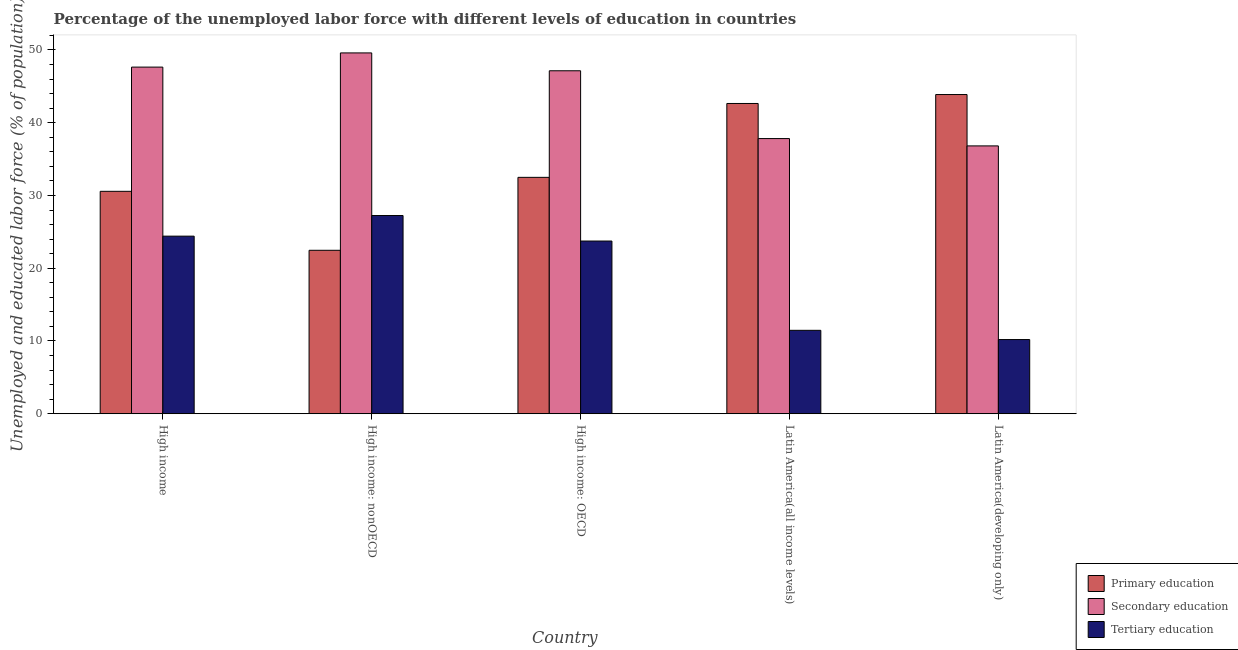How many groups of bars are there?
Offer a very short reply. 5. How many bars are there on the 4th tick from the left?
Provide a succinct answer. 3. What is the label of the 5th group of bars from the left?
Provide a short and direct response. Latin America(developing only). In how many cases, is the number of bars for a given country not equal to the number of legend labels?
Keep it short and to the point. 0. What is the percentage of labor force who received secondary education in High income: nonOECD?
Make the answer very short. 49.59. Across all countries, what is the maximum percentage of labor force who received primary education?
Your response must be concise. 43.87. Across all countries, what is the minimum percentage of labor force who received secondary education?
Your answer should be compact. 36.81. In which country was the percentage of labor force who received primary education maximum?
Your response must be concise. Latin America(developing only). In which country was the percentage of labor force who received tertiary education minimum?
Your answer should be very brief. Latin America(developing only). What is the total percentage of labor force who received primary education in the graph?
Make the answer very short. 172.03. What is the difference between the percentage of labor force who received tertiary education in High income: nonOECD and that in Latin America(all income levels)?
Your answer should be very brief. 15.78. What is the difference between the percentage of labor force who received secondary education in High income: OECD and the percentage of labor force who received tertiary education in Latin America(developing only)?
Your answer should be compact. 36.94. What is the average percentage of labor force who received tertiary education per country?
Your response must be concise. 19.41. What is the difference between the percentage of labor force who received primary education and percentage of labor force who received secondary education in High income?
Your answer should be compact. -17.07. In how many countries, is the percentage of labor force who received secondary education greater than 10 %?
Make the answer very short. 5. What is the ratio of the percentage of labor force who received primary education in High income: OECD to that in Latin America(developing only)?
Provide a short and direct response. 0.74. Is the percentage of labor force who received secondary education in High income less than that in High income: OECD?
Give a very brief answer. No. Is the difference between the percentage of labor force who received tertiary education in High income and Latin America(developing only) greater than the difference between the percentage of labor force who received secondary education in High income and Latin America(developing only)?
Your answer should be very brief. Yes. What is the difference between the highest and the second highest percentage of labor force who received tertiary education?
Provide a short and direct response. 2.84. What is the difference between the highest and the lowest percentage of labor force who received primary education?
Your answer should be compact. 21.41. In how many countries, is the percentage of labor force who received secondary education greater than the average percentage of labor force who received secondary education taken over all countries?
Offer a terse response. 3. Is the sum of the percentage of labor force who received secondary education in High income: nonOECD and Latin America(all income levels) greater than the maximum percentage of labor force who received primary education across all countries?
Ensure brevity in your answer.  Yes. What does the 3rd bar from the right in High income: nonOECD represents?
Your answer should be very brief. Primary education. Is it the case that in every country, the sum of the percentage of labor force who received primary education and percentage of labor force who received secondary education is greater than the percentage of labor force who received tertiary education?
Give a very brief answer. Yes. How many bars are there?
Offer a terse response. 15. Are all the bars in the graph horizontal?
Your response must be concise. No. How many countries are there in the graph?
Give a very brief answer. 5. Are the values on the major ticks of Y-axis written in scientific E-notation?
Your answer should be very brief. No. Where does the legend appear in the graph?
Offer a very short reply. Bottom right. How are the legend labels stacked?
Ensure brevity in your answer.  Vertical. What is the title of the graph?
Your answer should be compact. Percentage of the unemployed labor force with different levels of education in countries. What is the label or title of the Y-axis?
Keep it short and to the point. Unemployed and educated labor force (% of population). What is the Unemployed and educated labor force (% of population) in Primary education in High income?
Provide a succinct answer. 30.57. What is the Unemployed and educated labor force (% of population) in Secondary education in High income?
Your response must be concise. 47.64. What is the Unemployed and educated labor force (% of population) in Tertiary education in High income?
Provide a succinct answer. 24.41. What is the Unemployed and educated labor force (% of population) of Primary education in High income: nonOECD?
Your response must be concise. 22.46. What is the Unemployed and educated labor force (% of population) in Secondary education in High income: nonOECD?
Your answer should be compact. 49.59. What is the Unemployed and educated labor force (% of population) of Tertiary education in High income: nonOECD?
Offer a terse response. 27.24. What is the Unemployed and educated labor force (% of population) in Primary education in High income: OECD?
Your answer should be very brief. 32.49. What is the Unemployed and educated labor force (% of population) in Secondary education in High income: OECD?
Make the answer very short. 47.14. What is the Unemployed and educated labor force (% of population) of Tertiary education in High income: OECD?
Give a very brief answer. 23.74. What is the Unemployed and educated labor force (% of population) in Primary education in Latin America(all income levels)?
Offer a very short reply. 42.64. What is the Unemployed and educated labor force (% of population) in Secondary education in Latin America(all income levels)?
Your answer should be compact. 37.82. What is the Unemployed and educated labor force (% of population) of Tertiary education in Latin America(all income levels)?
Offer a very short reply. 11.46. What is the Unemployed and educated labor force (% of population) of Primary education in Latin America(developing only)?
Offer a terse response. 43.87. What is the Unemployed and educated labor force (% of population) in Secondary education in Latin America(developing only)?
Provide a succinct answer. 36.81. What is the Unemployed and educated labor force (% of population) in Tertiary education in Latin America(developing only)?
Make the answer very short. 10.2. Across all countries, what is the maximum Unemployed and educated labor force (% of population) in Primary education?
Offer a terse response. 43.87. Across all countries, what is the maximum Unemployed and educated labor force (% of population) of Secondary education?
Your answer should be compact. 49.59. Across all countries, what is the maximum Unemployed and educated labor force (% of population) of Tertiary education?
Keep it short and to the point. 27.24. Across all countries, what is the minimum Unemployed and educated labor force (% of population) of Primary education?
Offer a very short reply. 22.46. Across all countries, what is the minimum Unemployed and educated labor force (% of population) of Secondary education?
Keep it short and to the point. 36.81. Across all countries, what is the minimum Unemployed and educated labor force (% of population) in Tertiary education?
Ensure brevity in your answer.  10.2. What is the total Unemployed and educated labor force (% of population) of Primary education in the graph?
Provide a succinct answer. 172.03. What is the total Unemployed and educated labor force (% of population) of Secondary education in the graph?
Offer a terse response. 219. What is the total Unemployed and educated labor force (% of population) in Tertiary education in the graph?
Make the answer very short. 97.05. What is the difference between the Unemployed and educated labor force (% of population) in Primary education in High income and that in High income: nonOECD?
Keep it short and to the point. 8.1. What is the difference between the Unemployed and educated labor force (% of population) in Secondary education in High income and that in High income: nonOECD?
Offer a terse response. -1.95. What is the difference between the Unemployed and educated labor force (% of population) of Tertiary education in High income and that in High income: nonOECD?
Offer a terse response. -2.84. What is the difference between the Unemployed and educated labor force (% of population) in Primary education in High income and that in High income: OECD?
Your response must be concise. -1.92. What is the difference between the Unemployed and educated labor force (% of population) of Secondary education in High income and that in High income: OECD?
Your answer should be compact. 0.51. What is the difference between the Unemployed and educated labor force (% of population) of Tertiary education in High income and that in High income: OECD?
Ensure brevity in your answer.  0.67. What is the difference between the Unemployed and educated labor force (% of population) in Primary education in High income and that in Latin America(all income levels)?
Make the answer very short. -12.07. What is the difference between the Unemployed and educated labor force (% of population) of Secondary education in High income and that in Latin America(all income levels)?
Your answer should be very brief. 9.82. What is the difference between the Unemployed and educated labor force (% of population) in Tertiary education in High income and that in Latin America(all income levels)?
Your answer should be compact. 12.94. What is the difference between the Unemployed and educated labor force (% of population) in Primary education in High income and that in Latin America(developing only)?
Keep it short and to the point. -13.3. What is the difference between the Unemployed and educated labor force (% of population) in Secondary education in High income and that in Latin America(developing only)?
Keep it short and to the point. 10.83. What is the difference between the Unemployed and educated labor force (% of population) of Tertiary education in High income and that in Latin America(developing only)?
Ensure brevity in your answer.  14.21. What is the difference between the Unemployed and educated labor force (% of population) in Primary education in High income: nonOECD and that in High income: OECD?
Offer a very short reply. -10.02. What is the difference between the Unemployed and educated labor force (% of population) of Secondary education in High income: nonOECD and that in High income: OECD?
Make the answer very short. 2.45. What is the difference between the Unemployed and educated labor force (% of population) in Tertiary education in High income: nonOECD and that in High income: OECD?
Your answer should be very brief. 3.51. What is the difference between the Unemployed and educated labor force (% of population) in Primary education in High income: nonOECD and that in Latin America(all income levels)?
Make the answer very short. -20.18. What is the difference between the Unemployed and educated labor force (% of population) of Secondary education in High income: nonOECD and that in Latin America(all income levels)?
Your response must be concise. 11.77. What is the difference between the Unemployed and educated labor force (% of population) of Tertiary education in High income: nonOECD and that in Latin America(all income levels)?
Make the answer very short. 15.78. What is the difference between the Unemployed and educated labor force (% of population) in Primary education in High income: nonOECD and that in Latin America(developing only)?
Offer a terse response. -21.41. What is the difference between the Unemployed and educated labor force (% of population) in Secondary education in High income: nonOECD and that in Latin America(developing only)?
Keep it short and to the point. 12.78. What is the difference between the Unemployed and educated labor force (% of population) in Tertiary education in High income: nonOECD and that in Latin America(developing only)?
Give a very brief answer. 17.05. What is the difference between the Unemployed and educated labor force (% of population) in Primary education in High income: OECD and that in Latin America(all income levels)?
Give a very brief answer. -10.15. What is the difference between the Unemployed and educated labor force (% of population) of Secondary education in High income: OECD and that in Latin America(all income levels)?
Make the answer very short. 9.32. What is the difference between the Unemployed and educated labor force (% of population) of Tertiary education in High income: OECD and that in Latin America(all income levels)?
Ensure brevity in your answer.  12.27. What is the difference between the Unemployed and educated labor force (% of population) of Primary education in High income: OECD and that in Latin America(developing only)?
Provide a succinct answer. -11.38. What is the difference between the Unemployed and educated labor force (% of population) of Secondary education in High income: OECD and that in Latin America(developing only)?
Your response must be concise. 10.33. What is the difference between the Unemployed and educated labor force (% of population) in Tertiary education in High income: OECD and that in Latin America(developing only)?
Make the answer very short. 13.54. What is the difference between the Unemployed and educated labor force (% of population) in Primary education in Latin America(all income levels) and that in Latin America(developing only)?
Provide a succinct answer. -1.23. What is the difference between the Unemployed and educated labor force (% of population) of Secondary education in Latin America(all income levels) and that in Latin America(developing only)?
Your response must be concise. 1.01. What is the difference between the Unemployed and educated labor force (% of population) in Tertiary education in Latin America(all income levels) and that in Latin America(developing only)?
Keep it short and to the point. 1.27. What is the difference between the Unemployed and educated labor force (% of population) in Primary education in High income and the Unemployed and educated labor force (% of population) in Secondary education in High income: nonOECD?
Your answer should be compact. -19.02. What is the difference between the Unemployed and educated labor force (% of population) of Primary education in High income and the Unemployed and educated labor force (% of population) of Tertiary education in High income: nonOECD?
Offer a terse response. 3.33. What is the difference between the Unemployed and educated labor force (% of population) of Secondary education in High income and the Unemployed and educated labor force (% of population) of Tertiary education in High income: nonOECD?
Keep it short and to the point. 20.4. What is the difference between the Unemployed and educated labor force (% of population) of Primary education in High income and the Unemployed and educated labor force (% of population) of Secondary education in High income: OECD?
Provide a short and direct response. -16.57. What is the difference between the Unemployed and educated labor force (% of population) in Primary education in High income and the Unemployed and educated labor force (% of population) in Tertiary education in High income: OECD?
Give a very brief answer. 6.83. What is the difference between the Unemployed and educated labor force (% of population) in Secondary education in High income and the Unemployed and educated labor force (% of population) in Tertiary education in High income: OECD?
Make the answer very short. 23.91. What is the difference between the Unemployed and educated labor force (% of population) of Primary education in High income and the Unemployed and educated labor force (% of population) of Secondary education in Latin America(all income levels)?
Your answer should be compact. -7.25. What is the difference between the Unemployed and educated labor force (% of population) in Primary education in High income and the Unemployed and educated labor force (% of population) in Tertiary education in Latin America(all income levels)?
Offer a very short reply. 19.1. What is the difference between the Unemployed and educated labor force (% of population) of Secondary education in High income and the Unemployed and educated labor force (% of population) of Tertiary education in Latin America(all income levels)?
Provide a succinct answer. 36.18. What is the difference between the Unemployed and educated labor force (% of population) of Primary education in High income and the Unemployed and educated labor force (% of population) of Secondary education in Latin America(developing only)?
Provide a succinct answer. -6.24. What is the difference between the Unemployed and educated labor force (% of population) in Primary education in High income and the Unemployed and educated labor force (% of population) in Tertiary education in Latin America(developing only)?
Offer a terse response. 20.37. What is the difference between the Unemployed and educated labor force (% of population) in Secondary education in High income and the Unemployed and educated labor force (% of population) in Tertiary education in Latin America(developing only)?
Make the answer very short. 37.45. What is the difference between the Unemployed and educated labor force (% of population) in Primary education in High income: nonOECD and the Unemployed and educated labor force (% of population) in Secondary education in High income: OECD?
Your answer should be compact. -24.67. What is the difference between the Unemployed and educated labor force (% of population) in Primary education in High income: nonOECD and the Unemployed and educated labor force (% of population) in Tertiary education in High income: OECD?
Offer a very short reply. -1.27. What is the difference between the Unemployed and educated labor force (% of population) of Secondary education in High income: nonOECD and the Unemployed and educated labor force (% of population) of Tertiary education in High income: OECD?
Offer a very short reply. 25.86. What is the difference between the Unemployed and educated labor force (% of population) in Primary education in High income: nonOECD and the Unemployed and educated labor force (% of population) in Secondary education in Latin America(all income levels)?
Give a very brief answer. -15.35. What is the difference between the Unemployed and educated labor force (% of population) in Primary education in High income: nonOECD and the Unemployed and educated labor force (% of population) in Tertiary education in Latin America(all income levels)?
Keep it short and to the point. 11. What is the difference between the Unemployed and educated labor force (% of population) of Secondary education in High income: nonOECD and the Unemployed and educated labor force (% of population) of Tertiary education in Latin America(all income levels)?
Ensure brevity in your answer.  38.13. What is the difference between the Unemployed and educated labor force (% of population) of Primary education in High income: nonOECD and the Unemployed and educated labor force (% of population) of Secondary education in Latin America(developing only)?
Provide a succinct answer. -14.35. What is the difference between the Unemployed and educated labor force (% of population) in Primary education in High income: nonOECD and the Unemployed and educated labor force (% of population) in Tertiary education in Latin America(developing only)?
Provide a short and direct response. 12.27. What is the difference between the Unemployed and educated labor force (% of population) of Secondary education in High income: nonOECD and the Unemployed and educated labor force (% of population) of Tertiary education in Latin America(developing only)?
Keep it short and to the point. 39.39. What is the difference between the Unemployed and educated labor force (% of population) in Primary education in High income: OECD and the Unemployed and educated labor force (% of population) in Secondary education in Latin America(all income levels)?
Provide a short and direct response. -5.33. What is the difference between the Unemployed and educated labor force (% of population) of Primary education in High income: OECD and the Unemployed and educated labor force (% of population) of Tertiary education in Latin America(all income levels)?
Offer a terse response. 21.02. What is the difference between the Unemployed and educated labor force (% of population) of Secondary education in High income: OECD and the Unemployed and educated labor force (% of population) of Tertiary education in Latin America(all income levels)?
Offer a very short reply. 35.67. What is the difference between the Unemployed and educated labor force (% of population) in Primary education in High income: OECD and the Unemployed and educated labor force (% of population) in Secondary education in Latin America(developing only)?
Offer a very short reply. -4.32. What is the difference between the Unemployed and educated labor force (% of population) in Primary education in High income: OECD and the Unemployed and educated labor force (% of population) in Tertiary education in Latin America(developing only)?
Your answer should be compact. 22.29. What is the difference between the Unemployed and educated labor force (% of population) in Secondary education in High income: OECD and the Unemployed and educated labor force (% of population) in Tertiary education in Latin America(developing only)?
Keep it short and to the point. 36.94. What is the difference between the Unemployed and educated labor force (% of population) in Primary education in Latin America(all income levels) and the Unemployed and educated labor force (% of population) in Secondary education in Latin America(developing only)?
Offer a terse response. 5.83. What is the difference between the Unemployed and educated labor force (% of population) of Primary education in Latin America(all income levels) and the Unemployed and educated labor force (% of population) of Tertiary education in Latin America(developing only)?
Your answer should be compact. 32.45. What is the difference between the Unemployed and educated labor force (% of population) in Secondary education in Latin America(all income levels) and the Unemployed and educated labor force (% of population) in Tertiary education in Latin America(developing only)?
Make the answer very short. 27.62. What is the average Unemployed and educated labor force (% of population) in Primary education per country?
Give a very brief answer. 34.41. What is the average Unemployed and educated labor force (% of population) in Secondary education per country?
Your answer should be very brief. 43.8. What is the average Unemployed and educated labor force (% of population) of Tertiary education per country?
Your response must be concise. 19.41. What is the difference between the Unemployed and educated labor force (% of population) in Primary education and Unemployed and educated labor force (% of population) in Secondary education in High income?
Provide a short and direct response. -17.07. What is the difference between the Unemployed and educated labor force (% of population) of Primary education and Unemployed and educated labor force (% of population) of Tertiary education in High income?
Make the answer very short. 6.16. What is the difference between the Unemployed and educated labor force (% of population) in Secondary education and Unemployed and educated labor force (% of population) in Tertiary education in High income?
Your response must be concise. 23.23. What is the difference between the Unemployed and educated labor force (% of population) of Primary education and Unemployed and educated labor force (% of population) of Secondary education in High income: nonOECD?
Make the answer very short. -27.13. What is the difference between the Unemployed and educated labor force (% of population) of Primary education and Unemployed and educated labor force (% of population) of Tertiary education in High income: nonOECD?
Your answer should be compact. -4.78. What is the difference between the Unemployed and educated labor force (% of population) in Secondary education and Unemployed and educated labor force (% of population) in Tertiary education in High income: nonOECD?
Your answer should be very brief. 22.35. What is the difference between the Unemployed and educated labor force (% of population) in Primary education and Unemployed and educated labor force (% of population) in Secondary education in High income: OECD?
Your answer should be compact. -14.65. What is the difference between the Unemployed and educated labor force (% of population) in Primary education and Unemployed and educated labor force (% of population) in Tertiary education in High income: OECD?
Your answer should be compact. 8.75. What is the difference between the Unemployed and educated labor force (% of population) in Secondary education and Unemployed and educated labor force (% of population) in Tertiary education in High income: OECD?
Keep it short and to the point. 23.4. What is the difference between the Unemployed and educated labor force (% of population) in Primary education and Unemployed and educated labor force (% of population) in Secondary education in Latin America(all income levels)?
Provide a succinct answer. 4.82. What is the difference between the Unemployed and educated labor force (% of population) of Primary education and Unemployed and educated labor force (% of population) of Tertiary education in Latin America(all income levels)?
Give a very brief answer. 31.18. What is the difference between the Unemployed and educated labor force (% of population) in Secondary education and Unemployed and educated labor force (% of population) in Tertiary education in Latin America(all income levels)?
Offer a very short reply. 26.35. What is the difference between the Unemployed and educated labor force (% of population) in Primary education and Unemployed and educated labor force (% of population) in Secondary education in Latin America(developing only)?
Keep it short and to the point. 7.06. What is the difference between the Unemployed and educated labor force (% of population) in Primary education and Unemployed and educated labor force (% of population) in Tertiary education in Latin America(developing only)?
Offer a terse response. 33.67. What is the difference between the Unemployed and educated labor force (% of population) of Secondary education and Unemployed and educated labor force (% of population) of Tertiary education in Latin America(developing only)?
Provide a succinct answer. 26.62. What is the ratio of the Unemployed and educated labor force (% of population) of Primary education in High income to that in High income: nonOECD?
Provide a short and direct response. 1.36. What is the ratio of the Unemployed and educated labor force (% of population) in Secondary education in High income to that in High income: nonOECD?
Give a very brief answer. 0.96. What is the ratio of the Unemployed and educated labor force (% of population) in Tertiary education in High income to that in High income: nonOECD?
Give a very brief answer. 0.9. What is the ratio of the Unemployed and educated labor force (% of population) in Primary education in High income to that in High income: OECD?
Keep it short and to the point. 0.94. What is the ratio of the Unemployed and educated labor force (% of population) in Secondary education in High income to that in High income: OECD?
Your answer should be very brief. 1.01. What is the ratio of the Unemployed and educated labor force (% of population) in Tertiary education in High income to that in High income: OECD?
Your answer should be very brief. 1.03. What is the ratio of the Unemployed and educated labor force (% of population) in Primary education in High income to that in Latin America(all income levels)?
Offer a terse response. 0.72. What is the ratio of the Unemployed and educated labor force (% of population) in Secondary education in High income to that in Latin America(all income levels)?
Your response must be concise. 1.26. What is the ratio of the Unemployed and educated labor force (% of population) of Tertiary education in High income to that in Latin America(all income levels)?
Provide a succinct answer. 2.13. What is the ratio of the Unemployed and educated labor force (% of population) of Primary education in High income to that in Latin America(developing only)?
Provide a succinct answer. 0.7. What is the ratio of the Unemployed and educated labor force (% of population) in Secondary education in High income to that in Latin America(developing only)?
Provide a succinct answer. 1.29. What is the ratio of the Unemployed and educated labor force (% of population) of Tertiary education in High income to that in Latin America(developing only)?
Your answer should be compact. 2.39. What is the ratio of the Unemployed and educated labor force (% of population) of Primary education in High income: nonOECD to that in High income: OECD?
Your answer should be very brief. 0.69. What is the ratio of the Unemployed and educated labor force (% of population) in Secondary education in High income: nonOECD to that in High income: OECD?
Your answer should be compact. 1.05. What is the ratio of the Unemployed and educated labor force (% of population) of Tertiary education in High income: nonOECD to that in High income: OECD?
Give a very brief answer. 1.15. What is the ratio of the Unemployed and educated labor force (% of population) in Primary education in High income: nonOECD to that in Latin America(all income levels)?
Your response must be concise. 0.53. What is the ratio of the Unemployed and educated labor force (% of population) of Secondary education in High income: nonOECD to that in Latin America(all income levels)?
Your answer should be very brief. 1.31. What is the ratio of the Unemployed and educated labor force (% of population) of Tertiary education in High income: nonOECD to that in Latin America(all income levels)?
Offer a terse response. 2.38. What is the ratio of the Unemployed and educated labor force (% of population) in Primary education in High income: nonOECD to that in Latin America(developing only)?
Provide a succinct answer. 0.51. What is the ratio of the Unemployed and educated labor force (% of population) in Secondary education in High income: nonOECD to that in Latin America(developing only)?
Your answer should be very brief. 1.35. What is the ratio of the Unemployed and educated labor force (% of population) of Tertiary education in High income: nonOECD to that in Latin America(developing only)?
Your answer should be very brief. 2.67. What is the ratio of the Unemployed and educated labor force (% of population) in Primary education in High income: OECD to that in Latin America(all income levels)?
Make the answer very short. 0.76. What is the ratio of the Unemployed and educated labor force (% of population) in Secondary education in High income: OECD to that in Latin America(all income levels)?
Provide a succinct answer. 1.25. What is the ratio of the Unemployed and educated labor force (% of population) in Tertiary education in High income: OECD to that in Latin America(all income levels)?
Make the answer very short. 2.07. What is the ratio of the Unemployed and educated labor force (% of population) of Primary education in High income: OECD to that in Latin America(developing only)?
Make the answer very short. 0.74. What is the ratio of the Unemployed and educated labor force (% of population) in Secondary education in High income: OECD to that in Latin America(developing only)?
Provide a succinct answer. 1.28. What is the ratio of the Unemployed and educated labor force (% of population) of Tertiary education in High income: OECD to that in Latin America(developing only)?
Your answer should be compact. 2.33. What is the ratio of the Unemployed and educated labor force (% of population) of Secondary education in Latin America(all income levels) to that in Latin America(developing only)?
Ensure brevity in your answer.  1.03. What is the ratio of the Unemployed and educated labor force (% of population) of Tertiary education in Latin America(all income levels) to that in Latin America(developing only)?
Keep it short and to the point. 1.12. What is the difference between the highest and the second highest Unemployed and educated labor force (% of population) in Primary education?
Give a very brief answer. 1.23. What is the difference between the highest and the second highest Unemployed and educated labor force (% of population) of Secondary education?
Offer a terse response. 1.95. What is the difference between the highest and the second highest Unemployed and educated labor force (% of population) of Tertiary education?
Ensure brevity in your answer.  2.84. What is the difference between the highest and the lowest Unemployed and educated labor force (% of population) in Primary education?
Keep it short and to the point. 21.41. What is the difference between the highest and the lowest Unemployed and educated labor force (% of population) in Secondary education?
Offer a terse response. 12.78. What is the difference between the highest and the lowest Unemployed and educated labor force (% of population) in Tertiary education?
Provide a short and direct response. 17.05. 